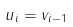Convert formula to latex. <formula><loc_0><loc_0><loc_500><loc_500>u _ { i } = v _ { i - 1 }</formula> 